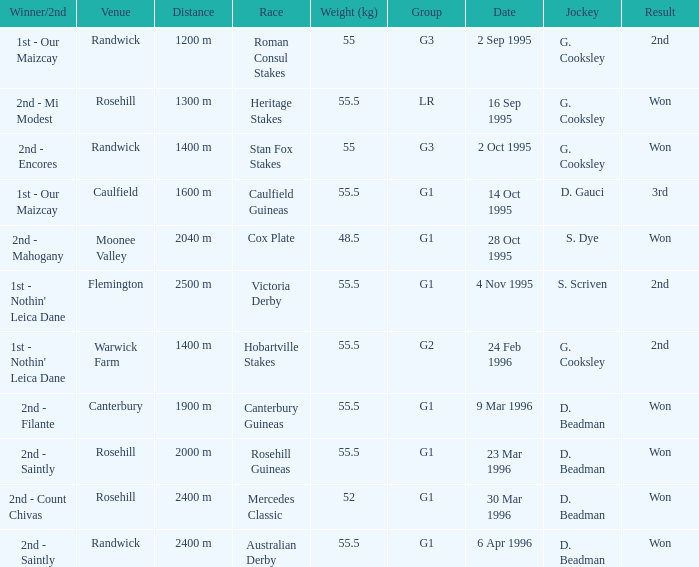What venue hosted the stan fox stakes? Randwick. 